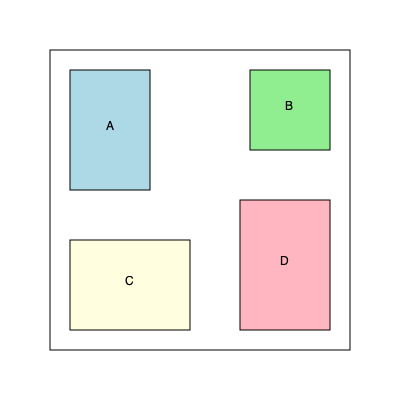Based on the top-down floor plan, which equipment arrangement maximizes workspace efficiency by minimizing unused space between the four pieces of equipment (A, B, C, and D)? To determine the optimal arrangement, we need to analyze the current layout and consider alternative configurations:

1. Current layout:
   - Equipment A: 80x120 units
   - Equipment B: 80x80 units
   - Equipment C: 120x90 units
   - Equipment D: 90x130 units

2. Analyze unused space:
   - There's significant space between B and D
   - Some space between A and C
   - Corners have unused areas

3. Consider alternative arrangements:
   a) Move B down next to D
   b) Rotate C 90 degrees and place it in the bottom-left corner
   c) Slide A to the right, adjacent to B

4. Optimal arrangement:
   - A: Top-right corner
   - B: Top-left corner
   - C: Bottom-left corner (rotated 90 degrees)
   - D: Bottom-right corner

5. Benefits of the new arrangement:
   - Minimizes gaps between equipment
   - Utilizes corner spaces more effectively
   - Creates a more compact overall layout

This arrangement maximizes workspace efficiency by reducing unused space and creating a more streamlined floor plan.
Answer: A: top-right, B: top-left, C: bottom-left (rotated), D: bottom-right 